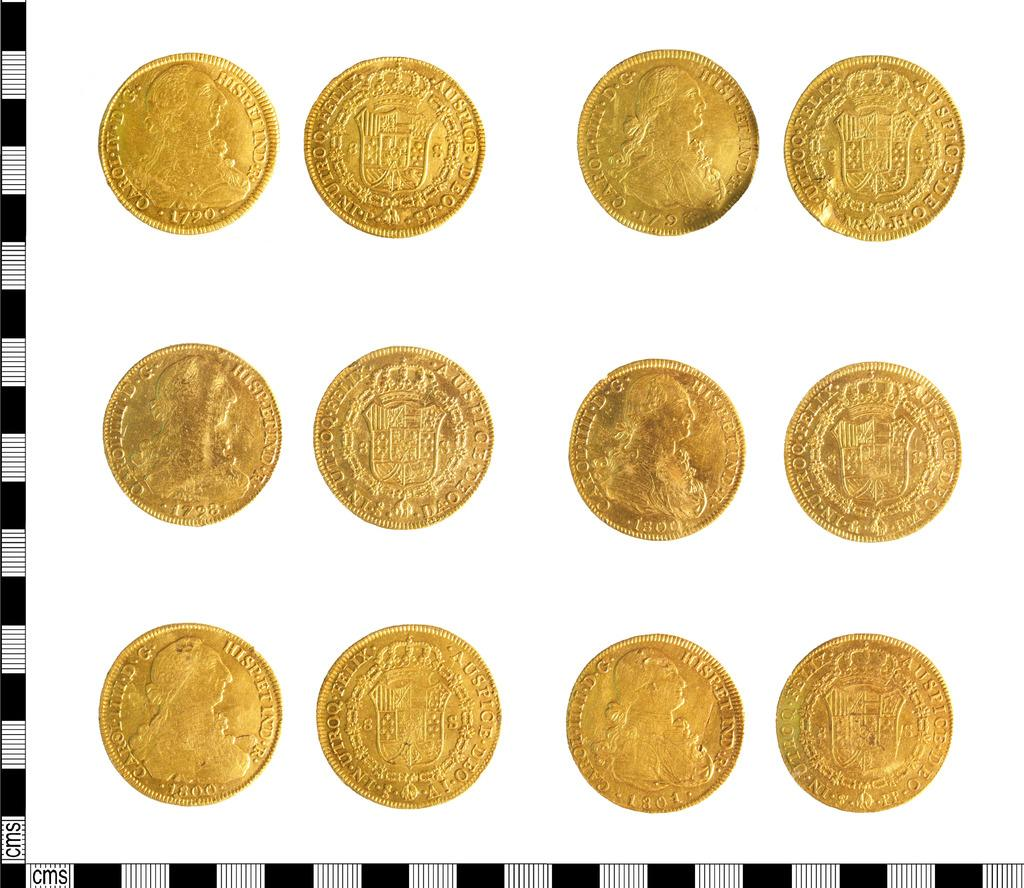Provide a one-sentence caption for the provided image. rows of gold coins with one of them labeled 'caroi'. 